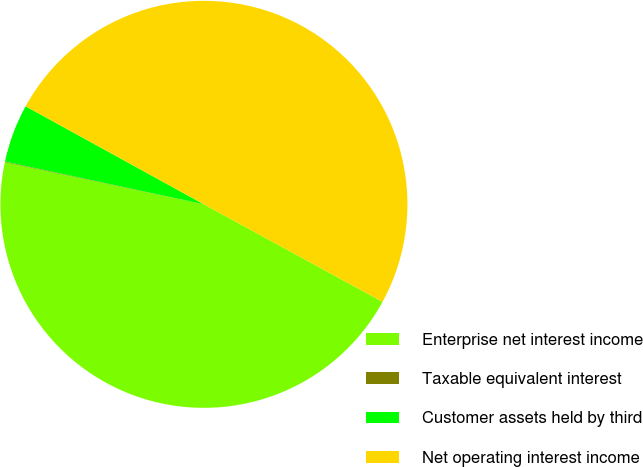<chart> <loc_0><loc_0><loc_500><loc_500><pie_chart><fcel>Enterprise net interest income<fcel>Taxable equivalent interest<fcel>Customer assets held by third<fcel>Net operating interest income<nl><fcel>45.37%<fcel>0.05%<fcel>4.63%<fcel>49.95%<nl></chart> 